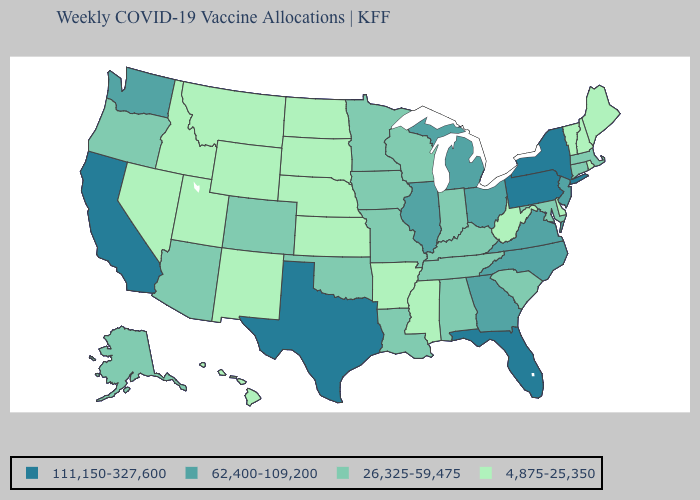How many symbols are there in the legend?
Answer briefly. 4. What is the highest value in states that border Louisiana?
Quick response, please. 111,150-327,600. Which states have the lowest value in the USA?
Quick response, please. Arkansas, Delaware, Hawaii, Idaho, Kansas, Maine, Mississippi, Montana, Nebraska, Nevada, New Hampshire, New Mexico, North Dakota, Rhode Island, South Dakota, Utah, Vermont, West Virginia, Wyoming. What is the value of Pennsylvania?
Quick response, please. 111,150-327,600. Does California have a higher value than Arkansas?
Keep it brief. Yes. Among the states that border New York , which have the highest value?
Be succinct. Pennsylvania. How many symbols are there in the legend?
Concise answer only. 4. Name the states that have a value in the range 4,875-25,350?
Give a very brief answer. Arkansas, Delaware, Hawaii, Idaho, Kansas, Maine, Mississippi, Montana, Nebraska, Nevada, New Hampshire, New Mexico, North Dakota, Rhode Island, South Dakota, Utah, Vermont, West Virginia, Wyoming. How many symbols are there in the legend?
Give a very brief answer. 4. What is the highest value in the MidWest ?
Concise answer only. 62,400-109,200. Name the states that have a value in the range 111,150-327,600?
Concise answer only. California, Florida, New York, Pennsylvania, Texas. What is the highest value in the USA?
Short answer required. 111,150-327,600. Name the states that have a value in the range 26,325-59,475?
Quick response, please. Alabama, Alaska, Arizona, Colorado, Connecticut, Indiana, Iowa, Kentucky, Louisiana, Maryland, Massachusetts, Minnesota, Missouri, Oklahoma, Oregon, South Carolina, Tennessee, Wisconsin. Name the states that have a value in the range 111,150-327,600?
Answer briefly. California, Florida, New York, Pennsylvania, Texas. Which states have the highest value in the USA?
Be succinct. California, Florida, New York, Pennsylvania, Texas. 